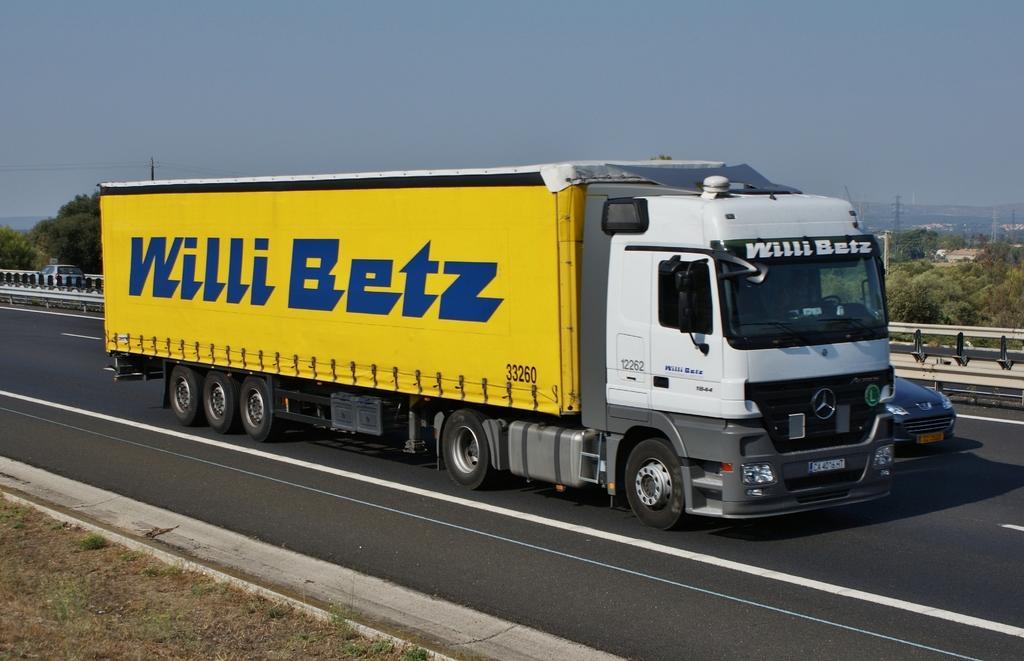Please provide a concise description of this image. In this picture we can see few vehicles on the road, beside to the road we can find fence, in the background we can see few trees and towers. 